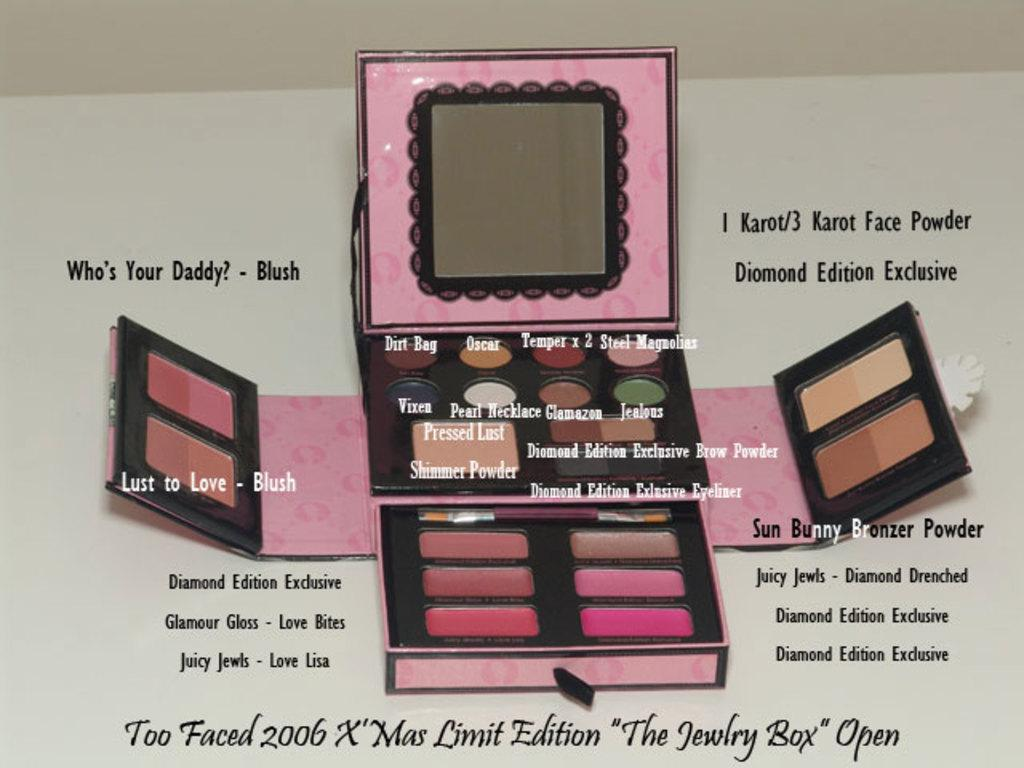Provide a one-sentence caption for the provided image. Too Faced 2006 X Mas limited edition makeup kit, detailing what each item is. 